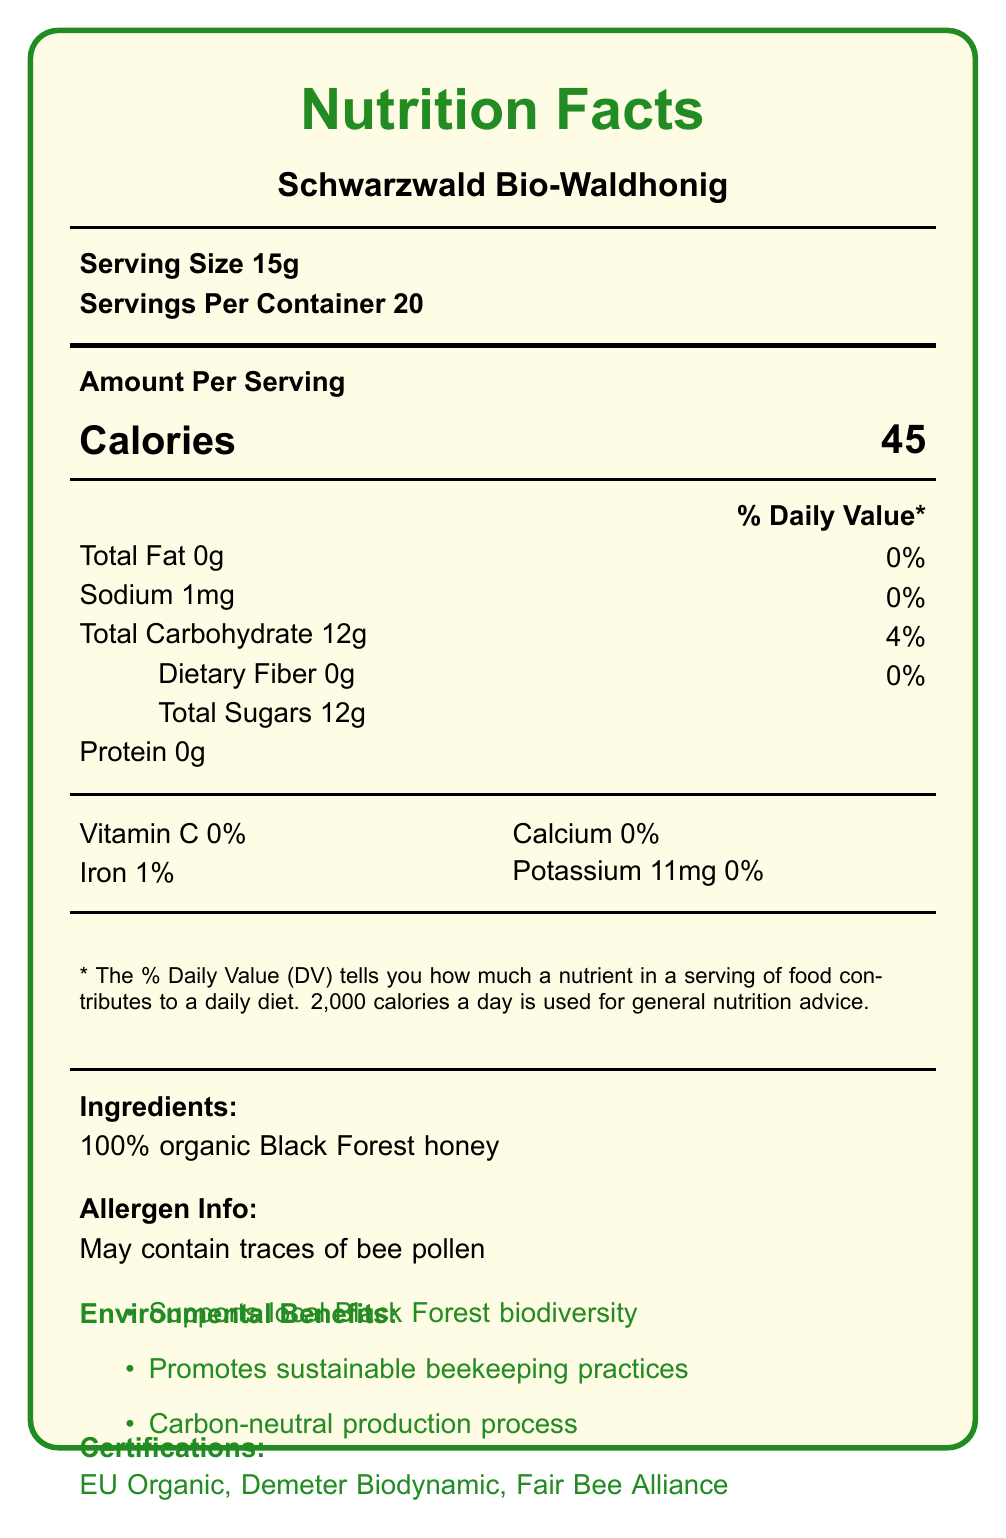what is the serving size? The serving size mentioned in the document is 15g.
Answer: 15g how many calories are there per serving? The document states that there are 45 calories per serving.
Answer: 45 what is the sodium content per serving? The sodium content per serving is listed as 1mg in the document.
Answer: 1mg how much total fat is in one serving? The document indicates that one serving contains 0g of total fat.
Answer: 0g what percentage of the Daily Value (%DV) of iron does one serving provide? According to the document, one serving provides 1% of the Daily Value for iron.
Answer: 1% what certifications does this honey have? A. EU Organic B. Fair Trade C. USDA Organic D. Fair Bee Alliance The document lists certifications for EU Organic and Fair Bee Alliance. It does not mention Fair Trade or USDA Organic.
Answer: A, D which of the following environmental benefits is associated with this honey? I. Supports rainforest biodiversity II. Promotes sustainable beekeeping practices III. Carbon-neutral production process The document specifies promoting sustainable beekeeping practices and having a carbon-neutral production process as environmental benefits.
Answer: II, III is the packaging recyclable? The document states that the honey comes in a 100% recyclable glass jar with a biodegradable label.
Answer: Yes summarize the main idea of this document. The document focuses on presenting nutritional information, sustainability statements, environmental benefits, and certifications for the honey product.
Answer: The document provides a Nutrition Facts label for Schwarzwald Bio-Waldhonig, a sustainably sourced German forest honey. It highlights its environmental benefits, certifications, nutritional content, and production details. what is the carbon footprint of this honey per jar? The document lists the carbon footprint of the honey as 0.8 kg CO2e per jar.
Answer: 0.8 kg CO2e per jar are there any allergens present in this honey? The document mentions that the honey may contain traces of bee pollen as an allergen.
Answer: May contain traces of bee pollen what is the percentage of Vitamin C in one serving? The document indicates that one serving contains 0% of the Daily Value for Vitamin C.
Answer: 0% where is Imkerei Schmidt GmbH located? According to the document, Imkerei Schmidt GmbH is based in Freiburg im Breisgau.
Answer: Freiburg im Breisgau how many servings are there per container? The document specifies that there are 20 servings per container.
Answer: 20 what is the total carbohydrate content per serving? The document states that the total carbohydrate content per serving is 12g.
Answer: 12g what percentage of the Daily Value for calcium does one serving provide? The document indicates that one serving provides 0% of the Daily Value for calcium.
Answer: 0% what is the protein content per serving? The document mentions that the protein content per serving is 0g.
Answer: 0g does the document mention if this honey supports Chancellor Merkel's initiative for biodiversity conservation? The sustainability statement in the document supports Chancellor Merkel's initiative for biodiversity conservation.
Answer: Yes what are the nutritional highlights of this honey? The document lists the honey's nutritional highlights as being rich in natural enzymes, containing antioxidants, and being a source of natural energy.
Answer: Rich in natural enzymes, contains antioxidants, source of natural energy what is the potassium content per serving? The document states that the potassium content per serving is 11mg.
Answer: 11mg does this honey meet German purity laws for honey production? The document confirms that the honey meets strict German purity laws for honey production.
Answer: Yes how is the production process of this honey described environmentally? The document describes the production process as carbon-neutral.
Answer: Carbon-neutral what is the percentage of daily value contributions like for dietary fiber? The document lists the dietary fiber content as 0g, which is 0% of the daily value.
Answer: 0% what are the other ingredients listed for this honey? The document lists the ingredients as 100% organic Black Forest honey.
Answer: 100% organic Black Forest honey what is the producer's name and location? The document states the producer's name is Imkerei Schmidt GmbH and is located in Freiburg im Breisgau.
Answer: Imkerei Schmidt GmbH, Freiburg im Breisgau what values are mentioned for total sugars per serving? The document states the total sugars content per serving is 12g.
Answer: 12g does the document provide any information on the exact price of this honey? The document does not provide any information related to the price of the honey.
Answer: Not enough information 